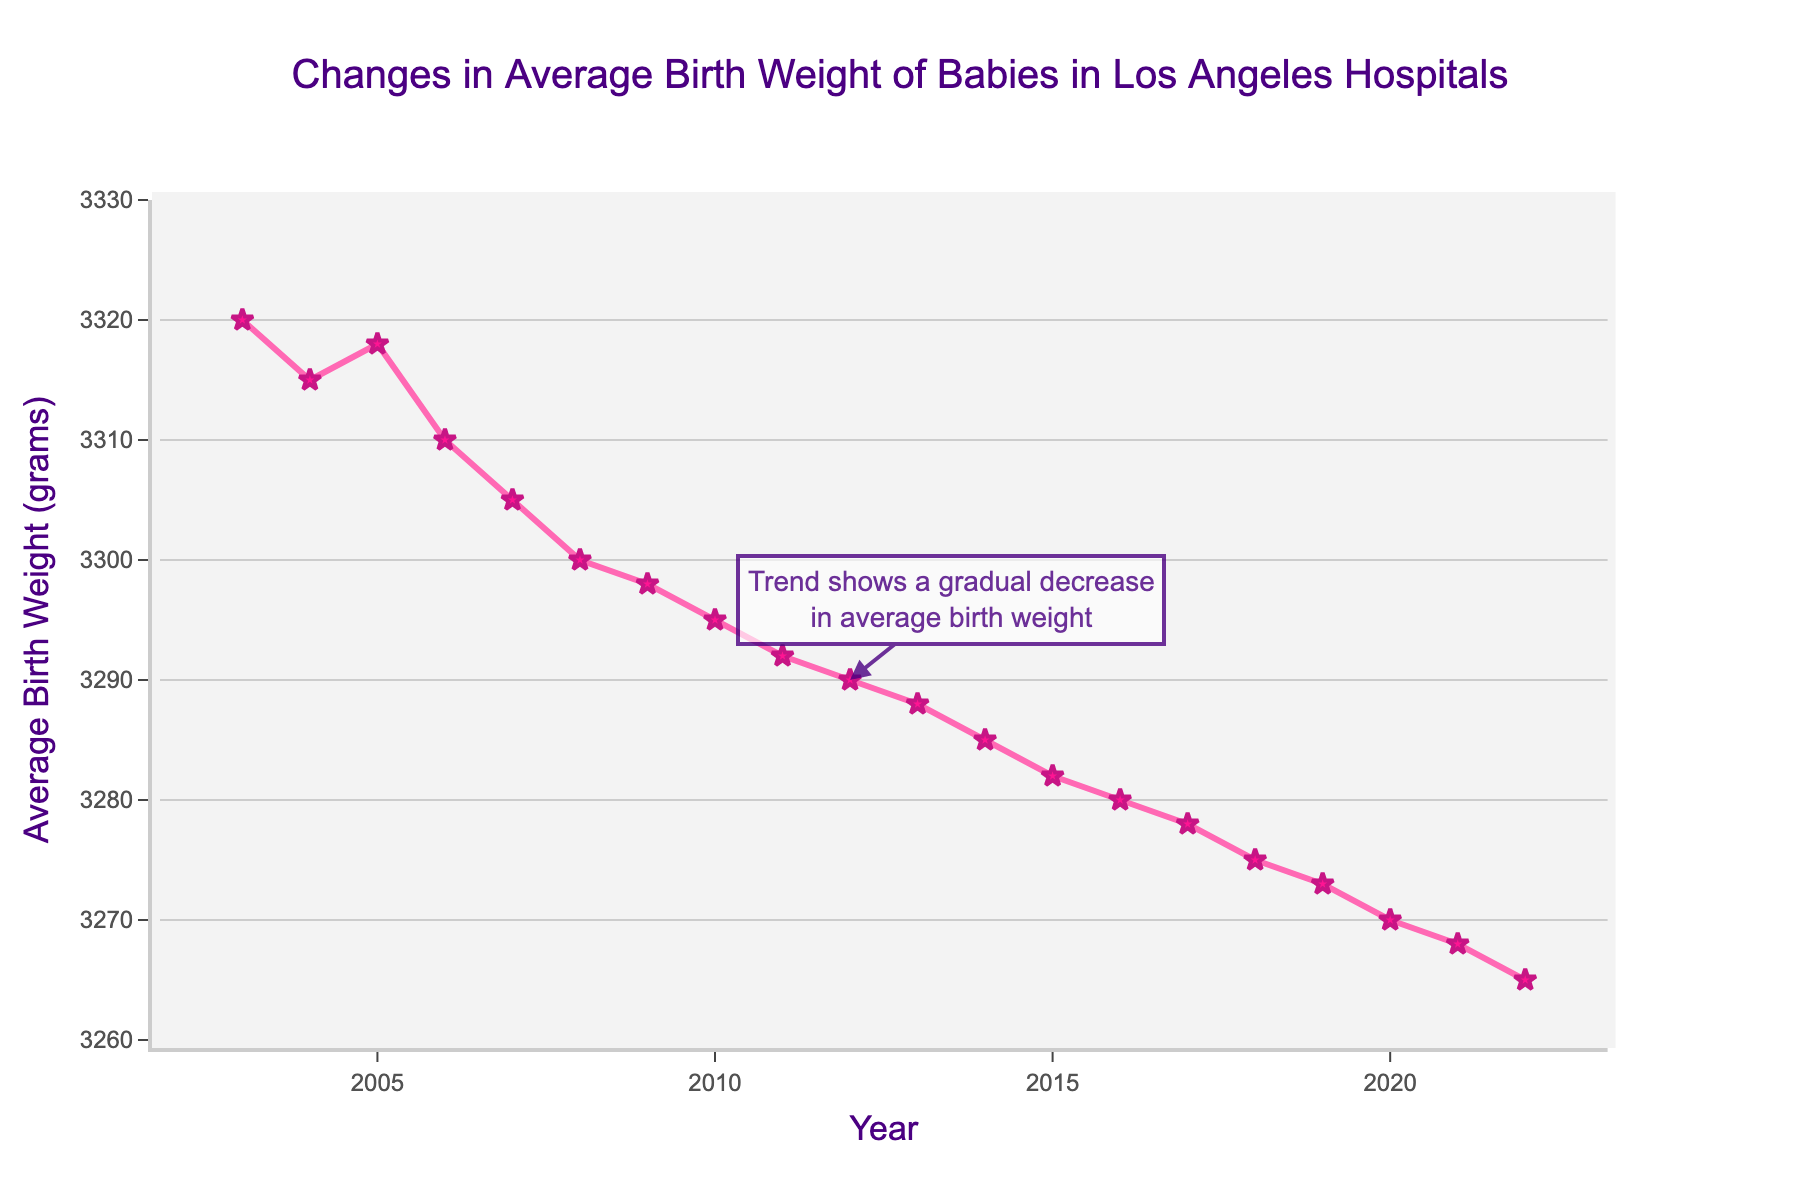What is the average birth weight in the year 2003? Look at the data point directly for the year 2003 and note the average birth weight.
Answer: 3320 grams How does the average birth weight in 2022 compare to that in 2003? Observe the data points for the years 2022 and 2003. Notice that 3320 grams in 2003 and 3265 grams in 2022, so the weight in 2022 is lower.
Answer: Lower Between which years did the average birth weight decrease the most? Review the changes in data points between consecutive years and identify the largest drop in value. The largest decrease is from 2006 (3310) to 2007 (3305).
Answer: 2006 and 2007 What is the range of average birth weights from 2003 to 2022? Determine the highest and lowest values within the given years: highest is 3320 grams in 2003 and lowest is 3265 grams in 2022. Subtract the lowest from the highest: 3320 - 3265 = 55 grams.
Answer: 55 grams What is the overall trend in average birth weight over the 20-year period? Observe the general direction of the lines on the graph from 2003 to 2022. Notice the consistent downward trend.
Answer: Decreasing In which year did the average birth weight first dip below 3300 grams? Identify the data point at which the value changes from above to below 3300 grams. In 2008, the value is 3300 grams.
Answer: 2008 By how much did the average birth weight change between 2010 and 2015? Note the values for 2010 (3295 grams) and 2015 (3282 grams), then find the difference: 3295 - 3282 = 13 grams.
Answer: 13 grams What specific visual elements help to interpret the trend in the average birth weight? Mention the line graph with markers, the annotation highlighting a trend, and the consistent downward slope. These elements guide the visual interpretation of the data.
Answer: Line graph with markers, annotation, downward slope Which year had the closest average birth weight to 3300 grams? Check the data points around 3300 grams and note the year that matches or is closest. This is 2008 with exactly 3300 grams.
Answer: 2008 